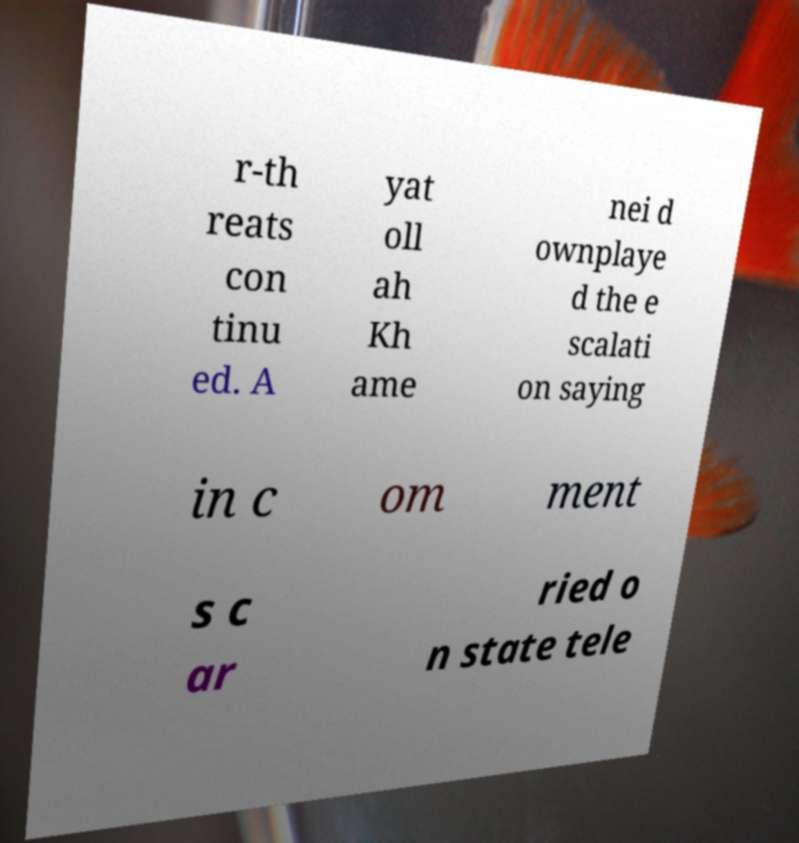For documentation purposes, I need the text within this image transcribed. Could you provide that? r-th reats con tinu ed. A yat oll ah Kh ame nei d ownplaye d the e scalati on saying in c om ment s c ar ried o n state tele 